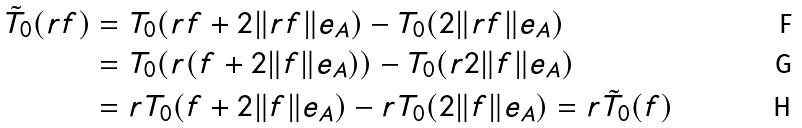<formula> <loc_0><loc_0><loc_500><loc_500>\tilde { T } _ { 0 } ( r f ) & = T _ { 0 } ( r f + 2 \| r f \| e _ { A } ) - T _ { 0 } ( 2 \| r f \| e _ { A } ) \\ & = T _ { 0 } ( r ( f + 2 \| f \| e _ { A } ) ) - T _ { 0 } ( r 2 \| f \| e _ { A } ) \\ & = r T _ { 0 } ( f + 2 \| f \| e _ { A } ) - r T _ { 0 } ( 2 \| f \| e _ { A } ) = r \tilde { T } _ { 0 } ( f )</formula> 